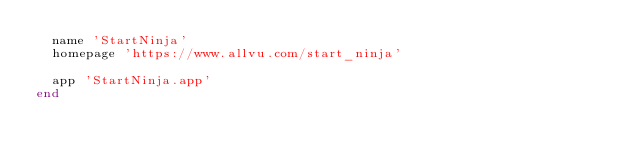<code> <loc_0><loc_0><loc_500><loc_500><_Ruby_>  name 'StartNinja'
  homepage 'https://www.allvu.com/start_ninja'

  app 'StartNinja.app'
end
</code> 